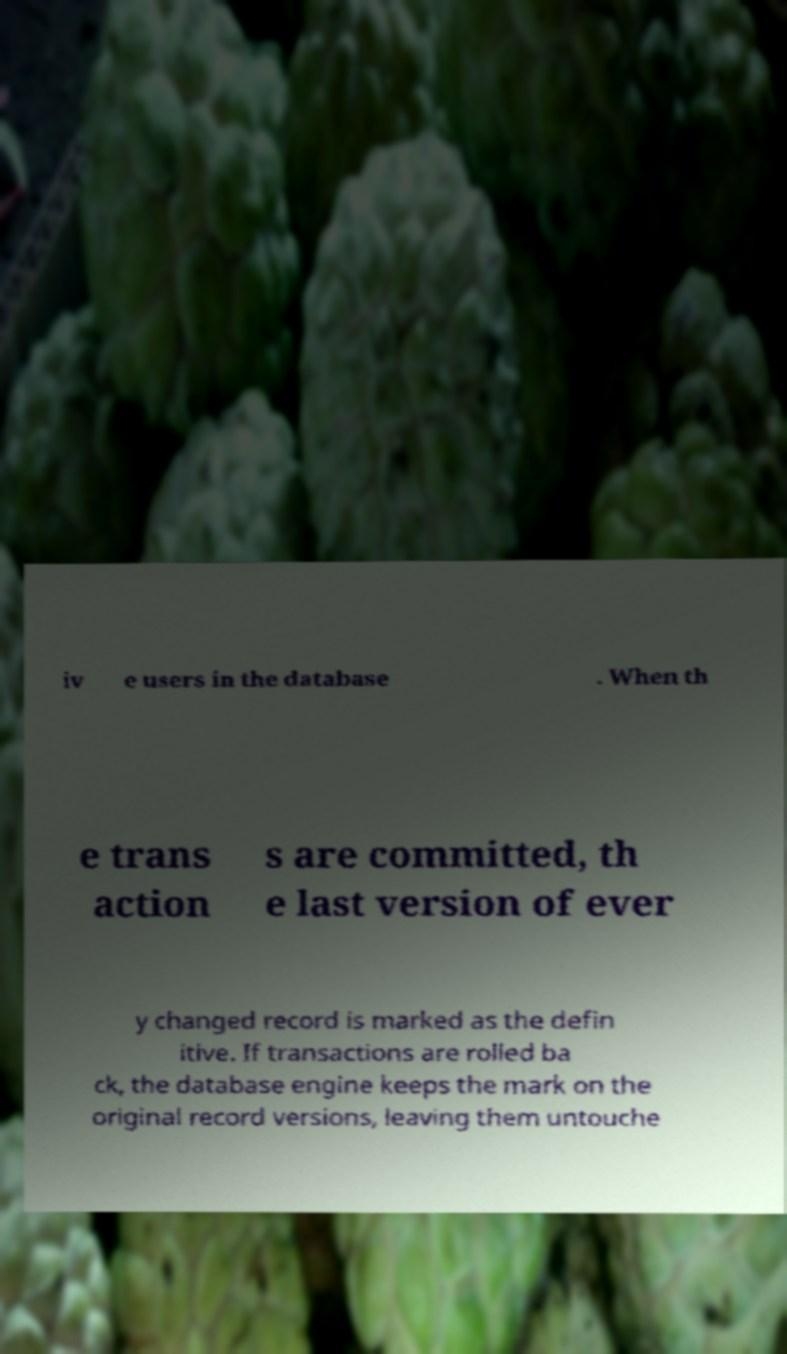Could you extract and type out the text from this image? iv e users in the database . When th e trans action s are committed, th e last version of ever y changed record is marked as the defin itive. If transactions are rolled ba ck, the database engine keeps the mark on the original record versions, leaving them untouche 